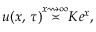<formula> <loc_0><loc_0><loc_500><loc_500>u ( x , \, \tau ) { \overset { x \right s q u i g a r r o w \infty } { \asymp } } K e ^ { x } ,</formula> 